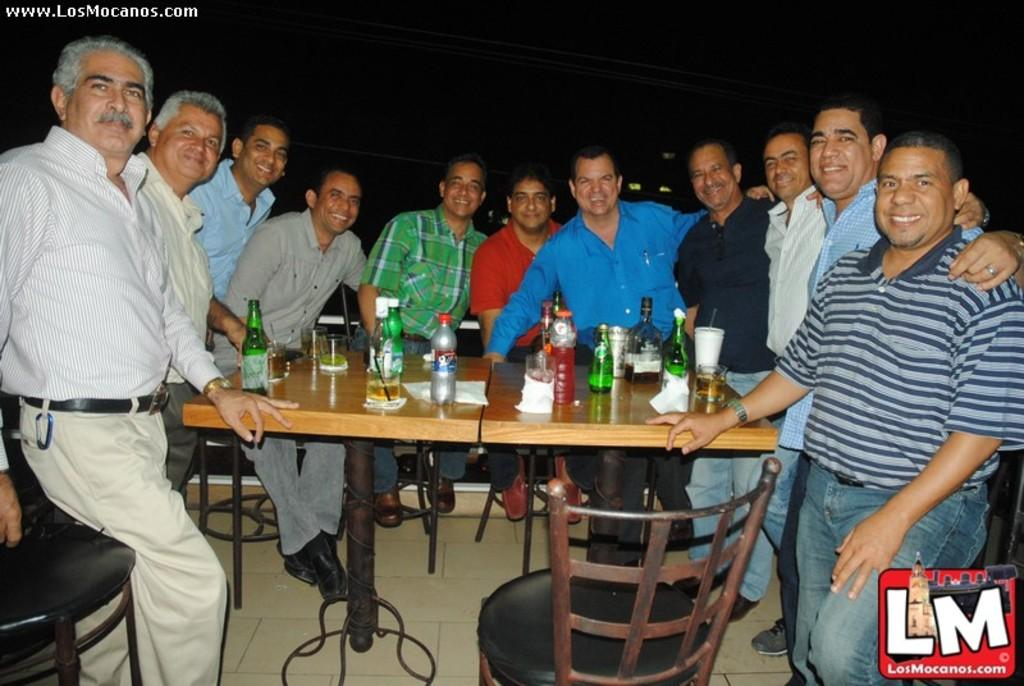What is the main subject of the image? The main subject of the image is a group of people standing. What objects can be seen in the image besides the people? There is a glass, a bottle, and tissues visible in the image. What type of snail can be seen crawling on the glass in the image? There is no snail present in the image; it only features a group of people and the mentioned objects. 